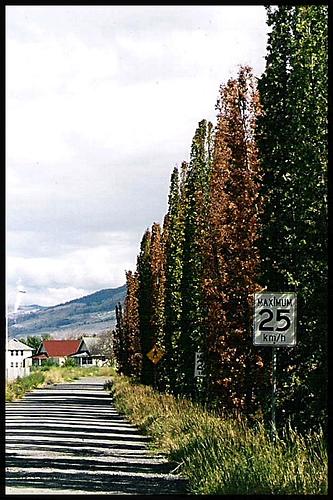What number is shown?
Concise answer only. 25. What is the speed limit?
Answer briefly. 25. Was this picture taken in the United States of America?
Quick response, please. No. 